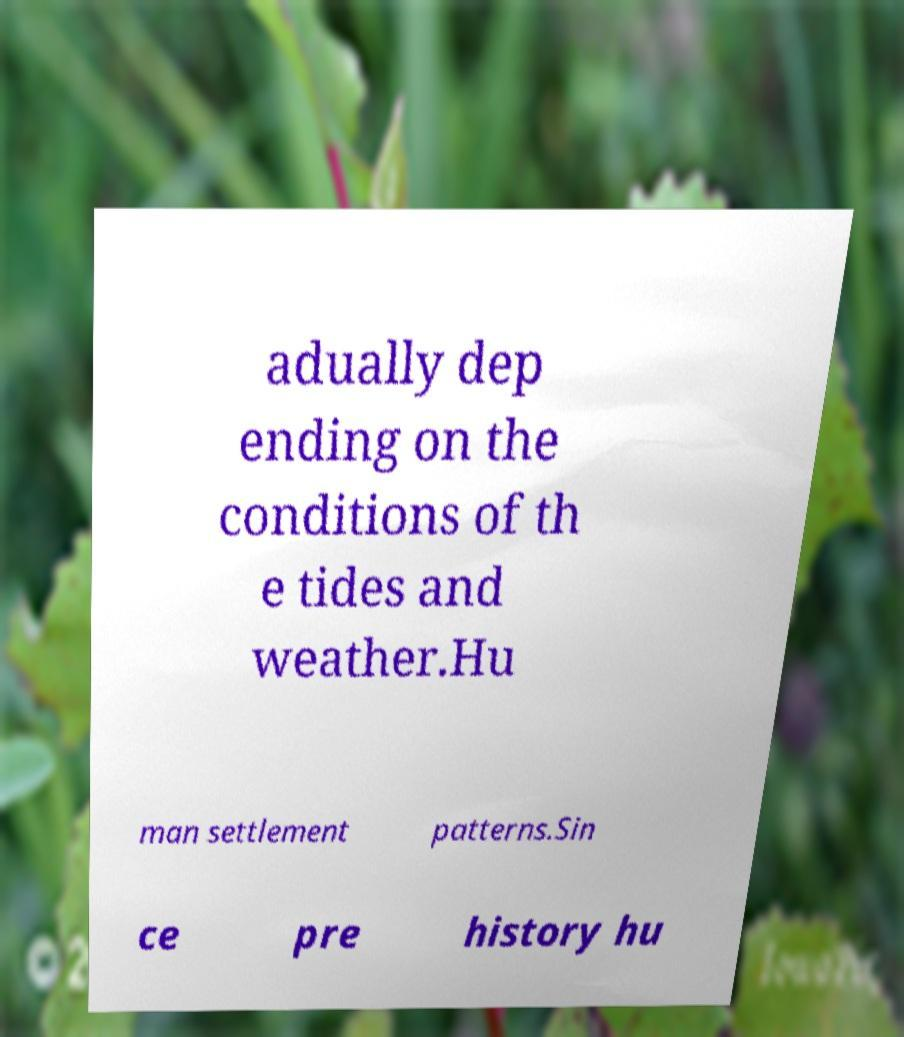Could you extract and type out the text from this image? adually dep ending on the conditions of th e tides and weather.Hu man settlement patterns.Sin ce pre history hu 